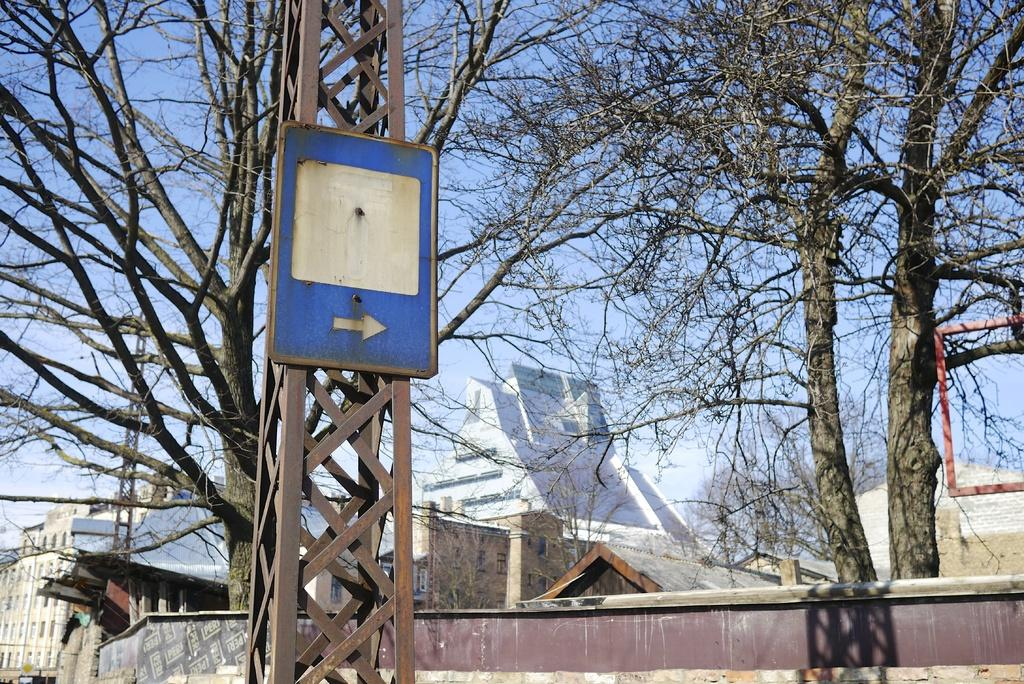What is the main object in the image? There is a sign board in the image. What other structures can be seen in the image? There is a tower, a building, and a wall in the image. What type of vegetation is present in the image? There are trees in the image. What is visible at the top of the image? The sky is visible at the top of the image. How many sisters are standing next to the wall in the image? There are no sisters present in the image. What type of cars can be seen parked near the building in the image? There are no cars present in the image. 